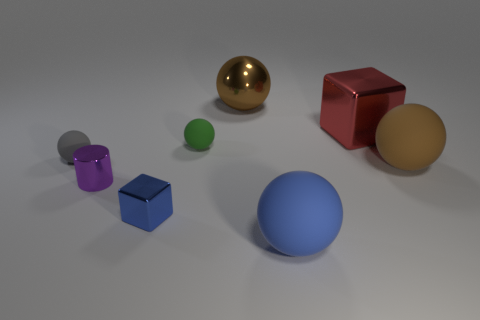Subtract all large brown matte balls. How many balls are left? 4 Subtract all blue balls. How many balls are left? 4 Subtract all green balls. Subtract all green cubes. How many balls are left? 4 Add 1 small purple metallic objects. How many objects exist? 9 Subtract all blocks. How many objects are left? 6 Subtract 1 blue spheres. How many objects are left? 7 Subtract all large blue spheres. Subtract all tiny metallic cubes. How many objects are left? 6 Add 2 purple cylinders. How many purple cylinders are left? 3 Add 6 blue balls. How many blue balls exist? 7 